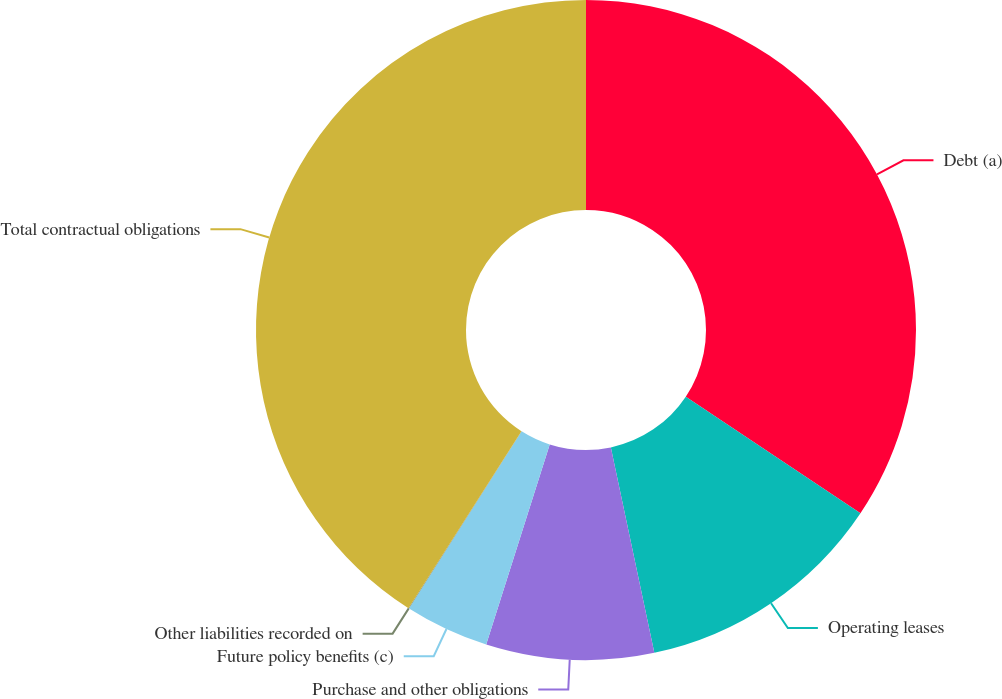Convert chart to OTSL. <chart><loc_0><loc_0><loc_500><loc_500><pie_chart><fcel>Debt (a)<fcel>Operating leases<fcel>Purchase and other obligations<fcel>Future policy benefits (c)<fcel>Other liabilities recorded on<fcel>Total contractual obligations<nl><fcel>34.37%<fcel>12.31%<fcel>8.21%<fcel>4.12%<fcel>0.03%<fcel>40.96%<nl></chart> 